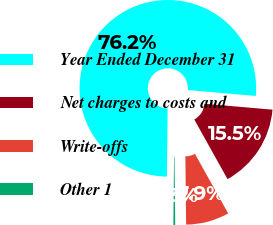Convert chart to OTSL. <chart><loc_0><loc_0><loc_500><loc_500><pie_chart><fcel>Year Ended December 31<fcel>Net charges to costs and<fcel>Write-offs<fcel>Other 1<nl><fcel>76.21%<fcel>15.52%<fcel>7.93%<fcel>0.34%<nl></chart> 